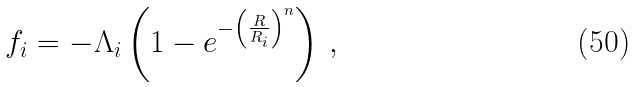Convert formula to latex. <formula><loc_0><loc_0><loc_500><loc_500>f _ { i } = - \Lambda _ { i } \left ( 1 - e ^ { - \left ( \frac { R } { R _ { i } } \right ) ^ { n } } \right ) \, ,</formula> 